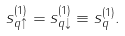Convert formula to latex. <formula><loc_0><loc_0><loc_500><loc_500>s _ { q \uparrow } ^ { ( 1 ) } = s _ { q \downarrow } ^ { ( 1 ) } \equiv s _ { q } ^ { ( 1 ) } .</formula> 